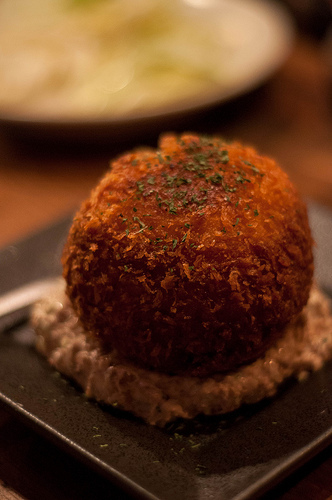<image>
Can you confirm if the cake is behind the food? No. The cake is not behind the food. From this viewpoint, the cake appears to be positioned elsewhere in the scene. 